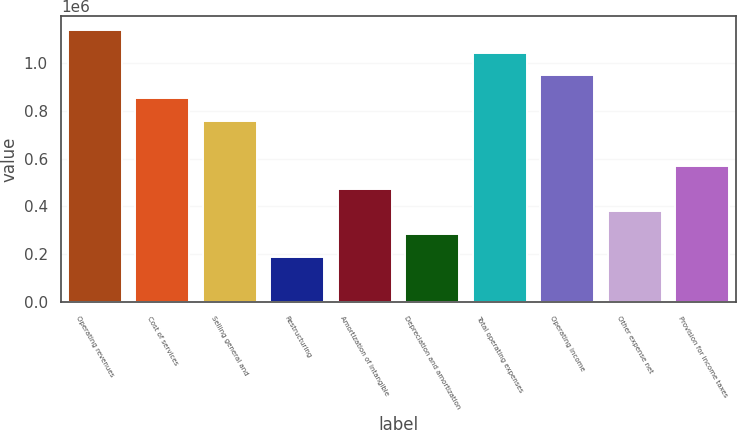<chart> <loc_0><loc_0><loc_500><loc_500><bar_chart><fcel>Operating revenues<fcel>Cost of services<fcel>Selling general and<fcel>Restructuring<fcel>Amortization of intangible<fcel>Depreciation and amortization<fcel>Total operating expenses<fcel>Operating income<fcel>Other expense net<fcel>Provision for income taxes<nl><fcel>1.14017e+06<fcel>855127<fcel>760113<fcel>190029<fcel>475071<fcel>285043<fcel>1.04515e+06<fcel>950141<fcel>380057<fcel>570085<nl></chart> 